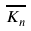<formula> <loc_0><loc_0><loc_500><loc_500>\overline { K _ { n } }</formula> 